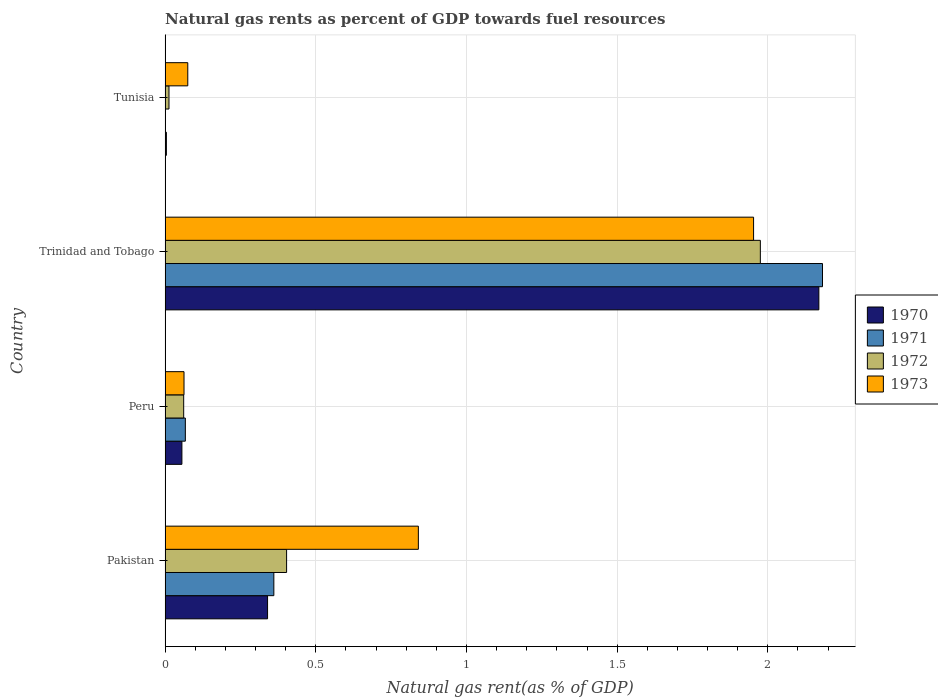How many different coloured bars are there?
Your answer should be very brief. 4. How many bars are there on the 1st tick from the bottom?
Offer a terse response. 4. What is the label of the 2nd group of bars from the top?
Make the answer very short. Trinidad and Tobago. What is the natural gas rent in 1972 in Tunisia?
Provide a succinct answer. 0.01. Across all countries, what is the maximum natural gas rent in 1971?
Ensure brevity in your answer.  2.18. Across all countries, what is the minimum natural gas rent in 1973?
Offer a very short reply. 0.06. In which country was the natural gas rent in 1971 maximum?
Offer a terse response. Trinidad and Tobago. In which country was the natural gas rent in 1971 minimum?
Your answer should be compact. Tunisia. What is the total natural gas rent in 1972 in the graph?
Provide a short and direct response. 2.45. What is the difference between the natural gas rent in 1973 in Peru and that in Trinidad and Tobago?
Provide a short and direct response. -1.89. What is the difference between the natural gas rent in 1971 in Trinidad and Tobago and the natural gas rent in 1970 in Pakistan?
Your answer should be very brief. 1.84. What is the average natural gas rent in 1973 per country?
Provide a short and direct response. 0.73. What is the difference between the natural gas rent in 1970 and natural gas rent in 1971 in Peru?
Your answer should be very brief. -0.01. In how many countries, is the natural gas rent in 1973 greater than 1.9 %?
Provide a short and direct response. 1. What is the ratio of the natural gas rent in 1971 in Peru to that in Trinidad and Tobago?
Your answer should be compact. 0.03. Is the natural gas rent in 1972 in Pakistan less than that in Tunisia?
Keep it short and to the point. No. What is the difference between the highest and the second highest natural gas rent in 1973?
Your response must be concise. 1.11. What is the difference between the highest and the lowest natural gas rent in 1971?
Make the answer very short. 2.18. In how many countries, is the natural gas rent in 1970 greater than the average natural gas rent in 1970 taken over all countries?
Offer a terse response. 1. Is it the case that in every country, the sum of the natural gas rent in 1973 and natural gas rent in 1970 is greater than the sum of natural gas rent in 1971 and natural gas rent in 1972?
Provide a succinct answer. No. Are all the bars in the graph horizontal?
Offer a terse response. Yes. Does the graph contain grids?
Keep it short and to the point. Yes. How many legend labels are there?
Provide a succinct answer. 4. How are the legend labels stacked?
Offer a very short reply. Vertical. What is the title of the graph?
Provide a succinct answer. Natural gas rents as percent of GDP towards fuel resources. Does "2008" appear as one of the legend labels in the graph?
Your answer should be very brief. No. What is the label or title of the X-axis?
Make the answer very short. Natural gas rent(as % of GDP). What is the Natural gas rent(as % of GDP) in 1970 in Pakistan?
Give a very brief answer. 0.34. What is the Natural gas rent(as % of GDP) in 1971 in Pakistan?
Provide a succinct answer. 0.36. What is the Natural gas rent(as % of GDP) in 1972 in Pakistan?
Give a very brief answer. 0.4. What is the Natural gas rent(as % of GDP) in 1973 in Pakistan?
Your answer should be very brief. 0.84. What is the Natural gas rent(as % of GDP) of 1970 in Peru?
Offer a terse response. 0.06. What is the Natural gas rent(as % of GDP) of 1971 in Peru?
Make the answer very short. 0.07. What is the Natural gas rent(as % of GDP) in 1972 in Peru?
Your answer should be compact. 0.06. What is the Natural gas rent(as % of GDP) of 1973 in Peru?
Your response must be concise. 0.06. What is the Natural gas rent(as % of GDP) of 1970 in Trinidad and Tobago?
Offer a very short reply. 2.17. What is the Natural gas rent(as % of GDP) in 1971 in Trinidad and Tobago?
Offer a terse response. 2.18. What is the Natural gas rent(as % of GDP) in 1972 in Trinidad and Tobago?
Offer a very short reply. 1.98. What is the Natural gas rent(as % of GDP) of 1973 in Trinidad and Tobago?
Your answer should be very brief. 1.95. What is the Natural gas rent(as % of GDP) of 1970 in Tunisia?
Offer a very short reply. 0. What is the Natural gas rent(as % of GDP) in 1971 in Tunisia?
Provide a short and direct response. 0. What is the Natural gas rent(as % of GDP) in 1972 in Tunisia?
Offer a very short reply. 0.01. What is the Natural gas rent(as % of GDP) of 1973 in Tunisia?
Make the answer very short. 0.08. Across all countries, what is the maximum Natural gas rent(as % of GDP) of 1970?
Offer a terse response. 2.17. Across all countries, what is the maximum Natural gas rent(as % of GDP) of 1971?
Offer a very short reply. 2.18. Across all countries, what is the maximum Natural gas rent(as % of GDP) in 1972?
Provide a short and direct response. 1.98. Across all countries, what is the maximum Natural gas rent(as % of GDP) of 1973?
Offer a terse response. 1.95. Across all countries, what is the minimum Natural gas rent(as % of GDP) in 1970?
Provide a succinct answer. 0. Across all countries, what is the minimum Natural gas rent(as % of GDP) of 1971?
Keep it short and to the point. 0. Across all countries, what is the minimum Natural gas rent(as % of GDP) of 1972?
Your answer should be very brief. 0.01. Across all countries, what is the minimum Natural gas rent(as % of GDP) of 1973?
Give a very brief answer. 0.06. What is the total Natural gas rent(as % of GDP) of 1970 in the graph?
Provide a short and direct response. 2.57. What is the total Natural gas rent(as % of GDP) in 1971 in the graph?
Provide a succinct answer. 2.61. What is the total Natural gas rent(as % of GDP) in 1972 in the graph?
Provide a succinct answer. 2.45. What is the total Natural gas rent(as % of GDP) in 1973 in the graph?
Your response must be concise. 2.93. What is the difference between the Natural gas rent(as % of GDP) of 1970 in Pakistan and that in Peru?
Your answer should be compact. 0.28. What is the difference between the Natural gas rent(as % of GDP) of 1971 in Pakistan and that in Peru?
Make the answer very short. 0.29. What is the difference between the Natural gas rent(as % of GDP) of 1972 in Pakistan and that in Peru?
Offer a very short reply. 0.34. What is the difference between the Natural gas rent(as % of GDP) in 1973 in Pakistan and that in Peru?
Offer a very short reply. 0.78. What is the difference between the Natural gas rent(as % of GDP) in 1970 in Pakistan and that in Trinidad and Tobago?
Offer a very short reply. -1.83. What is the difference between the Natural gas rent(as % of GDP) in 1971 in Pakistan and that in Trinidad and Tobago?
Provide a short and direct response. -1.82. What is the difference between the Natural gas rent(as % of GDP) of 1972 in Pakistan and that in Trinidad and Tobago?
Ensure brevity in your answer.  -1.57. What is the difference between the Natural gas rent(as % of GDP) of 1973 in Pakistan and that in Trinidad and Tobago?
Your answer should be compact. -1.11. What is the difference between the Natural gas rent(as % of GDP) of 1970 in Pakistan and that in Tunisia?
Make the answer very short. 0.34. What is the difference between the Natural gas rent(as % of GDP) of 1971 in Pakistan and that in Tunisia?
Your answer should be very brief. 0.36. What is the difference between the Natural gas rent(as % of GDP) in 1972 in Pakistan and that in Tunisia?
Keep it short and to the point. 0.39. What is the difference between the Natural gas rent(as % of GDP) of 1973 in Pakistan and that in Tunisia?
Offer a very short reply. 0.77. What is the difference between the Natural gas rent(as % of GDP) in 1970 in Peru and that in Trinidad and Tobago?
Your answer should be compact. -2.11. What is the difference between the Natural gas rent(as % of GDP) in 1971 in Peru and that in Trinidad and Tobago?
Provide a short and direct response. -2.11. What is the difference between the Natural gas rent(as % of GDP) in 1972 in Peru and that in Trinidad and Tobago?
Offer a terse response. -1.91. What is the difference between the Natural gas rent(as % of GDP) in 1973 in Peru and that in Trinidad and Tobago?
Give a very brief answer. -1.89. What is the difference between the Natural gas rent(as % of GDP) of 1970 in Peru and that in Tunisia?
Your answer should be compact. 0.05. What is the difference between the Natural gas rent(as % of GDP) of 1971 in Peru and that in Tunisia?
Give a very brief answer. 0.07. What is the difference between the Natural gas rent(as % of GDP) of 1972 in Peru and that in Tunisia?
Ensure brevity in your answer.  0.05. What is the difference between the Natural gas rent(as % of GDP) of 1973 in Peru and that in Tunisia?
Offer a very short reply. -0.01. What is the difference between the Natural gas rent(as % of GDP) of 1970 in Trinidad and Tobago and that in Tunisia?
Ensure brevity in your answer.  2.17. What is the difference between the Natural gas rent(as % of GDP) in 1971 in Trinidad and Tobago and that in Tunisia?
Provide a succinct answer. 2.18. What is the difference between the Natural gas rent(as % of GDP) in 1972 in Trinidad and Tobago and that in Tunisia?
Make the answer very short. 1.96. What is the difference between the Natural gas rent(as % of GDP) in 1973 in Trinidad and Tobago and that in Tunisia?
Offer a terse response. 1.88. What is the difference between the Natural gas rent(as % of GDP) in 1970 in Pakistan and the Natural gas rent(as % of GDP) in 1971 in Peru?
Make the answer very short. 0.27. What is the difference between the Natural gas rent(as % of GDP) in 1970 in Pakistan and the Natural gas rent(as % of GDP) in 1972 in Peru?
Provide a succinct answer. 0.28. What is the difference between the Natural gas rent(as % of GDP) of 1970 in Pakistan and the Natural gas rent(as % of GDP) of 1973 in Peru?
Keep it short and to the point. 0.28. What is the difference between the Natural gas rent(as % of GDP) of 1971 in Pakistan and the Natural gas rent(as % of GDP) of 1972 in Peru?
Ensure brevity in your answer.  0.3. What is the difference between the Natural gas rent(as % of GDP) of 1971 in Pakistan and the Natural gas rent(as % of GDP) of 1973 in Peru?
Provide a short and direct response. 0.3. What is the difference between the Natural gas rent(as % of GDP) of 1972 in Pakistan and the Natural gas rent(as % of GDP) of 1973 in Peru?
Your response must be concise. 0.34. What is the difference between the Natural gas rent(as % of GDP) in 1970 in Pakistan and the Natural gas rent(as % of GDP) in 1971 in Trinidad and Tobago?
Offer a terse response. -1.84. What is the difference between the Natural gas rent(as % of GDP) of 1970 in Pakistan and the Natural gas rent(as % of GDP) of 1972 in Trinidad and Tobago?
Give a very brief answer. -1.64. What is the difference between the Natural gas rent(as % of GDP) in 1970 in Pakistan and the Natural gas rent(as % of GDP) in 1973 in Trinidad and Tobago?
Your answer should be very brief. -1.61. What is the difference between the Natural gas rent(as % of GDP) of 1971 in Pakistan and the Natural gas rent(as % of GDP) of 1972 in Trinidad and Tobago?
Your answer should be very brief. -1.61. What is the difference between the Natural gas rent(as % of GDP) of 1971 in Pakistan and the Natural gas rent(as % of GDP) of 1973 in Trinidad and Tobago?
Keep it short and to the point. -1.59. What is the difference between the Natural gas rent(as % of GDP) in 1972 in Pakistan and the Natural gas rent(as % of GDP) in 1973 in Trinidad and Tobago?
Make the answer very short. -1.55. What is the difference between the Natural gas rent(as % of GDP) of 1970 in Pakistan and the Natural gas rent(as % of GDP) of 1971 in Tunisia?
Provide a short and direct response. 0.34. What is the difference between the Natural gas rent(as % of GDP) in 1970 in Pakistan and the Natural gas rent(as % of GDP) in 1972 in Tunisia?
Provide a succinct answer. 0.33. What is the difference between the Natural gas rent(as % of GDP) of 1970 in Pakistan and the Natural gas rent(as % of GDP) of 1973 in Tunisia?
Ensure brevity in your answer.  0.26. What is the difference between the Natural gas rent(as % of GDP) in 1971 in Pakistan and the Natural gas rent(as % of GDP) in 1972 in Tunisia?
Provide a succinct answer. 0.35. What is the difference between the Natural gas rent(as % of GDP) of 1971 in Pakistan and the Natural gas rent(as % of GDP) of 1973 in Tunisia?
Offer a terse response. 0.29. What is the difference between the Natural gas rent(as % of GDP) of 1972 in Pakistan and the Natural gas rent(as % of GDP) of 1973 in Tunisia?
Give a very brief answer. 0.33. What is the difference between the Natural gas rent(as % of GDP) in 1970 in Peru and the Natural gas rent(as % of GDP) in 1971 in Trinidad and Tobago?
Your answer should be compact. -2.13. What is the difference between the Natural gas rent(as % of GDP) of 1970 in Peru and the Natural gas rent(as % of GDP) of 1972 in Trinidad and Tobago?
Your answer should be compact. -1.92. What is the difference between the Natural gas rent(as % of GDP) in 1970 in Peru and the Natural gas rent(as % of GDP) in 1973 in Trinidad and Tobago?
Ensure brevity in your answer.  -1.9. What is the difference between the Natural gas rent(as % of GDP) of 1971 in Peru and the Natural gas rent(as % of GDP) of 1972 in Trinidad and Tobago?
Provide a succinct answer. -1.91. What is the difference between the Natural gas rent(as % of GDP) of 1971 in Peru and the Natural gas rent(as % of GDP) of 1973 in Trinidad and Tobago?
Give a very brief answer. -1.89. What is the difference between the Natural gas rent(as % of GDP) of 1972 in Peru and the Natural gas rent(as % of GDP) of 1973 in Trinidad and Tobago?
Your response must be concise. -1.89. What is the difference between the Natural gas rent(as % of GDP) in 1970 in Peru and the Natural gas rent(as % of GDP) in 1971 in Tunisia?
Provide a short and direct response. 0.06. What is the difference between the Natural gas rent(as % of GDP) of 1970 in Peru and the Natural gas rent(as % of GDP) of 1972 in Tunisia?
Keep it short and to the point. 0.04. What is the difference between the Natural gas rent(as % of GDP) in 1970 in Peru and the Natural gas rent(as % of GDP) in 1973 in Tunisia?
Ensure brevity in your answer.  -0.02. What is the difference between the Natural gas rent(as % of GDP) of 1971 in Peru and the Natural gas rent(as % of GDP) of 1972 in Tunisia?
Provide a succinct answer. 0.05. What is the difference between the Natural gas rent(as % of GDP) in 1971 in Peru and the Natural gas rent(as % of GDP) in 1973 in Tunisia?
Your answer should be compact. -0.01. What is the difference between the Natural gas rent(as % of GDP) of 1972 in Peru and the Natural gas rent(as % of GDP) of 1973 in Tunisia?
Give a very brief answer. -0.01. What is the difference between the Natural gas rent(as % of GDP) of 1970 in Trinidad and Tobago and the Natural gas rent(as % of GDP) of 1971 in Tunisia?
Offer a terse response. 2.17. What is the difference between the Natural gas rent(as % of GDP) of 1970 in Trinidad and Tobago and the Natural gas rent(as % of GDP) of 1972 in Tunisia?
Keep it short and to the point. 2.16. What is the difference between the Natural gas rent(as % of GDP) of 1970 in Trinidad and Tobago and the Natural gas rent(as % of GDP) of 1973 in Tunisia?
Provide a short and direct response. 2.09. What is the difference between the Natural gas rent(as % of GDP) in 1971 in Trinidad and Tobago and the Natural gas rent(as % of GDP) in 1972 in Tunisia?
Keep it short and to the point. 2.17. What is the difference between the Natural gas rent(as % of GDP) in 1971 in Trinidad and Tobago and the Natural gas rent(as % of GDP) in 1973 in Tunisia?
Your answer should be very brief. 2.11. What is the difference between the Natural gas rent(as % of GDP) in 1972 in Trinidad and Tobago and the Natural gas rent(as % of GDP) in 1973 in Tunisia?
Keep it short and to the point. 1.9. What is the average Natural gas rent(as % of GDP) of 1970 per country?
Your answer should be compact. 0.64. What is the average Natural gas rent(as % of GDP) of 1971 per country?
Make the answer very short. 0.65. What is the average Natural gas rent(as % of GDP) in 1972 per country?
Your answer should be very brief. 0.61. What is the average Natural gas rent(as % of GDP) in 1973 per country?
Your answer should be compact. 0.73. What is the difference between the Natural gas rent(as % of GDP) of 1970 and Natural gas rent(as % of GDP) of 1971 in Pakistan?
Give a very brief answer. -0.02. What is the difference between the Natural gas rent(as % of GDP) in 1970 and Natural gas rent(as % of GDP) in 1972 in Pakistan?
Provide a succinct answer. -0.06. What is the difference between the Natural gas rent(as % of GDP) of 1970 and Natural gas rent(as % of GDP) of 1973 in Pakistan?
Ensure brevity in your answer.  -0.5. What is the difference between the Natural gas rent(as % of GDP) of 1971 and Natural gas rent(as % of GDP) of 1972 in Pakistan?
Make the answer very short. -0.04. What is the difference between the Natural gas rent(as % of GDP) of 1971 and Natural gas rent(as % of GDP) of 1973 in Pakistan?
Your answer should be compact. -0.48. What is the difference between the Natural gas rent(as % of GDP) of 1972 and Natural gas rent(as % of GDP) of 1973 in Pakistan?
Your response must be concise. -0.44. What is the difference between the Natural gas rent(as % of GDP) in 1970 and Natural gas rent(as % of GDP) in 1971 in Peru?
Keep it short and to the point. -0.01. What is the difference between the Natural gas rent(as % of GDP) of 1970 and Natural gas rent(as % of GDP) of 1972 in Peru?
Keep it short and to the point. -0.01. What is the difference between the Natural gas rent(as % of GDP) of 1970 and Natural gas rent(as % of GDP) of 1973 in Peru?
Provide a succinct answer. -0.01. What is the difference between the Natural gas rent(as % of GDP) of 1971 and Natural gas rent(as % of GDP) of 1972 in Peru?
Your answer should be compact. 0.01. What is the difference between the Natural gas rent(as % of GDP) of 1971 and Natural gas rent(as % of GDP) of 1973 in Peru?
Give a very brief answer. 0. What is the difference between the Natural gas rent(as % of GDP) in 1972 and Natural gas rent(as % of GDP) in 1973 in Peru?
Your answer should be compact. -0. What is the difference between the Natural gas rent(as % of GDP) of 1970 and Natural gas rent(as % of GDP) of 1971 in Trinidad and Tobago?
Provide a short and direct response. -0.01. What is the difference between the Natural gas rent(as % of GDP) of 1970 and Natural gas rent(as % of GDP) of 1972 in Trinidad and Tobago?
Your response must be concise. 0.19. What is the difference between the Natural gas rent(as % of GDP) of 1970 and Natural gas rent(as % of GDP) of 1973 in Trinidad and Tobago?
Make the answer very short. 0.22. What is the difference between the Natural gas rent(as % of GDP) of 1971 and Natural gas rent(as % of GDP) of 1972 in Trinidad and Tobago?
Ensure brevity in your answer.  0.21. What is the difference between the Natural gas rent(as % of GDP) in 1971 and Natural gas rent(as % of GDP) in 1973 in Trinidad and Tobago?
Provide a succinct answer. 0.23. What is the difference between the Natural gas rent(as % of GDP) of 1972 and Natural gas rent(as % of GDP) of 1973 in Trinidad and Tobago?
Offer a terse response. 0.02. What is the difference between the Natural gas rent(as % of GDP) of 1970 and Natural gas rent(as % of GDP) of 1971 in Tunisia?
Provide a short and direct response. 0. What is the difference between the Natural gas rent(as % of GDP) in 1970 and Natural gas rent(as % of GDP) in 1972 in Tunisia?
Your response must be concise. -0.01. What is the difference between the Natural gas rent(as % of GDP) of 1970 and Natural gas rent(as % of GDP) of 1973 in Tunisia?
Ensure brevity in your answer.  -0.07. What is the difference between the Natural gas rent(as % of GDP) of 1971 and Natural gas rent(as % of GDP) of 1972 in Tunisia?
Provide a succinct answer. -0.01. What is the difference between the Natural gas rent(as % of GDP) of 1971 and Natural gas rent(as % of GDP) of 1973 in Tunisia?
Provide a succinct answer. -0.07. What is the difference between the Natural gas rent(as % of GDP) in 1972 and Natural gas rent(as % of GDP) in 1973 in Tunisia?
Offer a very short reply. -0.06. What is the ratio of the Natural gas rent(as % of GDP) of 1970 in Pakistan to that in Peru?
Give a very brief answer. 6.1. What is the ratio of the Natural gas rent(as % of GDP) in 1971 in Pakistan to that in Peru?
Provide a succinct answer. 5.37. What is the ratio of the Natural gas rent(as % of GDP) of 1972 in Pakistan to that in Peru?
Ensure brevity in your answer.  6.54. What is the ratio of the Natural gas rent(as % of GDP) in 1973 in Pakistan to that in Peru?
Give a very brief answer. 13.39. What is the ratio of the Natural gas rent(as % of GDP) in 1970 in Pakistan to that in Trinidad and Tobago?
Offer a terse response. 0.16. What is the ratio of the Natural gas rent(as % of GDP) in 1971 in Pakistan to that in Trinidad and Tobago?
Your answer should be compact. 0.17. What is the ratio of the Natural gas rent(as % of GDP) in 1972 in Pakistan to that in Trinidad and Tobago?
Provide a short and direct response. 0.2. What is the ratio of the Natural gas rent(as % of GDP) of 1973 in Pakistan to that in Trinidad and Tobago?
Your answer should be very brief. 0.43. What is the ratio of the Natural gas rent(as % of GDP) of 1970 in Pakistan to that in Tunisia?
Provide a succinct answer. 80.16. What is the ratio of the Natural gas rent(as % of GDP) in 1971 in Pakistan to that in Tunisia?
Ensure brevity in your answer.  486.4. What is the ratio of the Natural gas rent(as % of GDP) of 1972 in Pakistan to that in Tunisia?
Provide a short and direct response. 31.31. What is the ratio of the Natural gas rent(as % of GDP) of 1973 in Pakistan to that in Tunisia?
Make the answer very short. 11.17. What is the ratio of the Natural gas rent(as % of GDP) in 1970 in Peru to that in Trinidad and Tobago?
Offer a terse response. 0.03. What is the ratio of the Natural gas rent(as % of GDP) of 1971 in Peru to that in Trinidad and Tobago?
Provide a short and direct response. 0.03. What is the ratio of the Natural gas rent(as % of GDP) of 1972 in Peru to that in Trinidad and Tobago?
Your answer should be very brief. 0.03. What is the ratio of the Natural gas rent(as % of GDP) of 1973 in Peru to that in Trinidad and Tobago?
Provide a succinct answer. 0.03. What is the ratio of the Natural gas rent(as % of GDP) of 1970 in Peru to that in Tunisia?
Your answer should be very brief. 13.15. What is the ratio of the Natural gas rent(as % of GDP) of 1971 in Peru to that in Tunisia?
Ensure brevity in your answer.  90.55. What is the ratio of the Natural gas rent(as % of GDP) in 1972 in Peru to that in Tunisia?
Make the answer very short. 4.79. What is the ratio of the Natural gas rent(as % of GDP) of 1973 in Peru to that in Tunisia?
Ensure brevity in your answer.  0.83. What is the ratio of the Natural gas rent(as % of GDP) in 1970 in Trinidad and Tobago to that in Tunisia?
Your answer should be very brief. 511.49. What is the ratio of the Natural gas rent(as % of GDP) in 1971 in Trinidad and Tobago to that in Tunisia?
Give a very brief answer. 2940.6. What is the ratio of the Natural gas rent(as % of GDP) of 1972 in Trinidad and Tobago to that in Tunisia?
Provide a succinct answer. 153.39. What is the ratio of the Natural gas rent(as % of GDP) in 1973 in Trinidad and Tobago to that in Tunisia?
Offer a terse response. 25.94. What is the difference between the highest and the second highest Natural gas rent(as % of GDP) of 1970?
Your response must be concise. 1.83. What is the difference between the highest and the second highest Natural gas rent(as % of GDP) of 1971?
Give a very brief answer. 1.82. What is the difference between the highest and the second highest Natural gas rent(as % of GDP) of 1972?
Your response must be concise. 1.57. What is the difference between the highest and the second highest Natural gas rent(as % of GDP) of 1973?
Provide a succinct answer. 1.11. What is the difference between the highest and the lowest Natural gas rent(as % of GDP) in 1970?
Make the answer very short. 2.17. What is the difference between the highest and the lowest Natural gas rent(as % of GDP) in 1971?
Your answer should be compact. 2.18. What is the difference between the highest and the lowest Natural gas rent(as % of GDP) of 1972?
Provide a succinct answer. 1.96. What is the difference between the highest and the lowest Natural gas rent(as % of GDP) in 1973?
Offer a terse response. 1.89. 